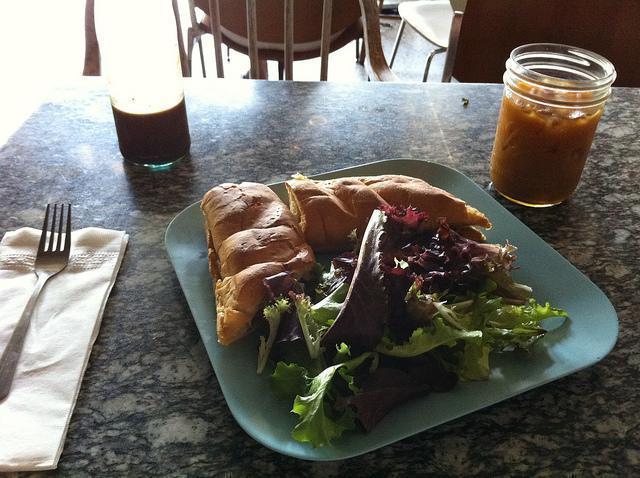What type of drink in in the jar?
From the following set of four choices, select the accurate answer to respond to the question.
Options: Wine, coke, 7-up, iced coffee. Iced coffee. 